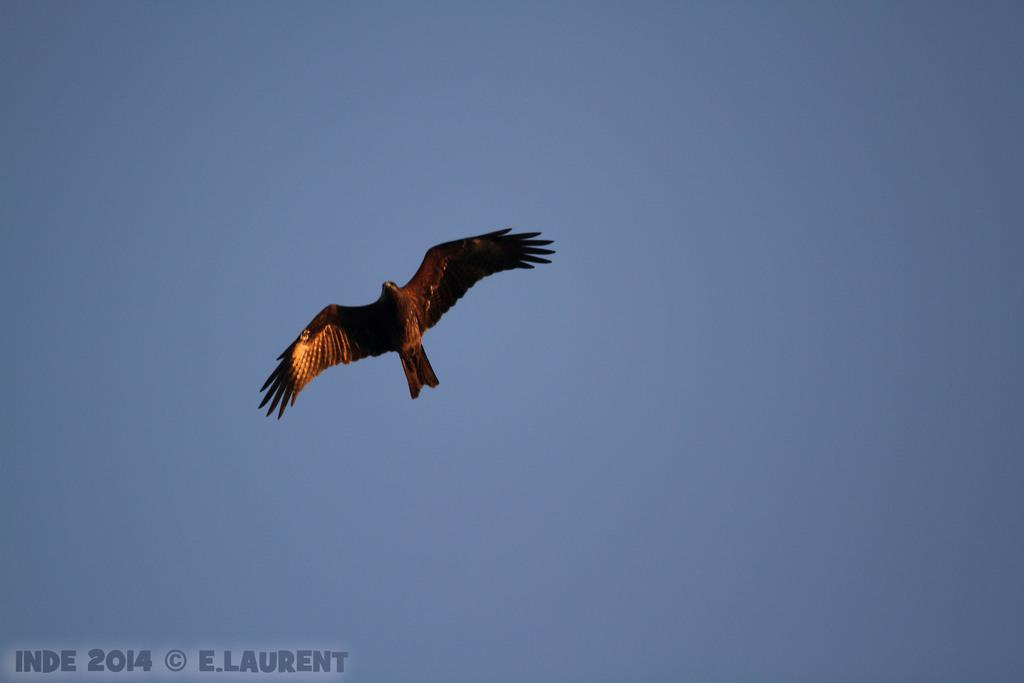What can be found on the bottom left of the image? There is a watermark on the bottom left of the image. What is happening on the left side of the image? There is a bird flying in the air on the left side of the image. What is the background of the image? The background of the image is the blue sky. What type of religious symbol can be seen on the bird's watch in the image? There is no bird wearing a watch or any religious symbol present in the image. 